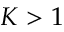Convert formula to latex. <formula><loc_0><loc_0><loc_500><loc_500>K > 1</formula> 